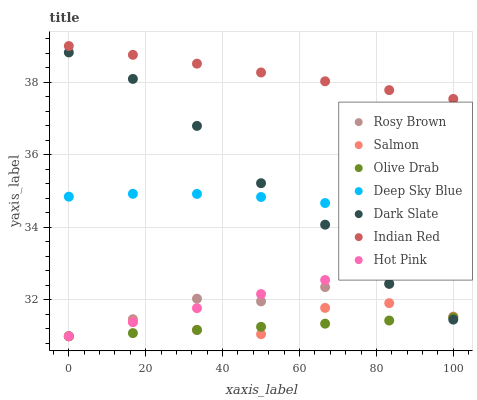Does Olive Drab have the minimum area under the curve?
Answer yes or no. Yes. Does Indian Red have the maximum area under the curve?
Answer yes or no. Yes. Does Deep Sky Blue have the minimum area under the curve?
Answer yes or no. No. Does Deep Sky Blue have the maximum area under the curve?
Answer yes or no. No. Is Olive Drab the smoothest?
Answer yes or no. Yes. Is Salmon the roughest?
Answer yes or no. Yes. Is Deep Sky Blue the smoothest?
Answer yes or no. No. Is Deep Sky Blue the roughest?
Answer yes or no. No. Does Hot Pink have the lowest value?
Answer yes or no. Yes. Does Deep Sky Blue have the lowest value?
Answer yes or no. No. Does Indian Red have the highest value?
Answer yes or no. Yes. Does Deep Sky Blue have the highest value?
Answer yes or no. No. Is Dark Slate less than Indian Red?
Answer yes or no. Yes. Is Indian Red greater than Deep Sky Blue?
Answer yes or no. Yes. Does Olive Drab intersect Dark Slate?
Answer yes or no. Yes. Is Olive Drab less than Dark Slate?
Answer yes or no. No. Is Olive Drab greater than Dark Slate?
Answer yes or no. No. Does Dark Slate intersect Indian Red?
Answer yes or no. No. 